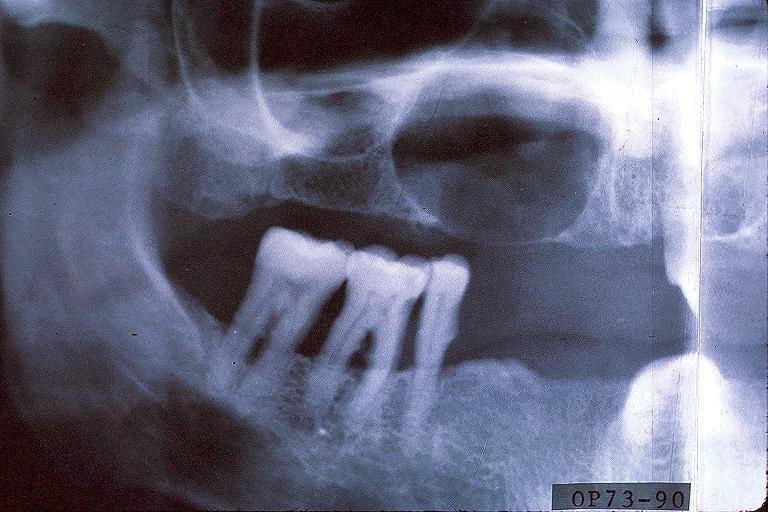what does this image show?
Answer the question using a single word or phrase. Cyst 